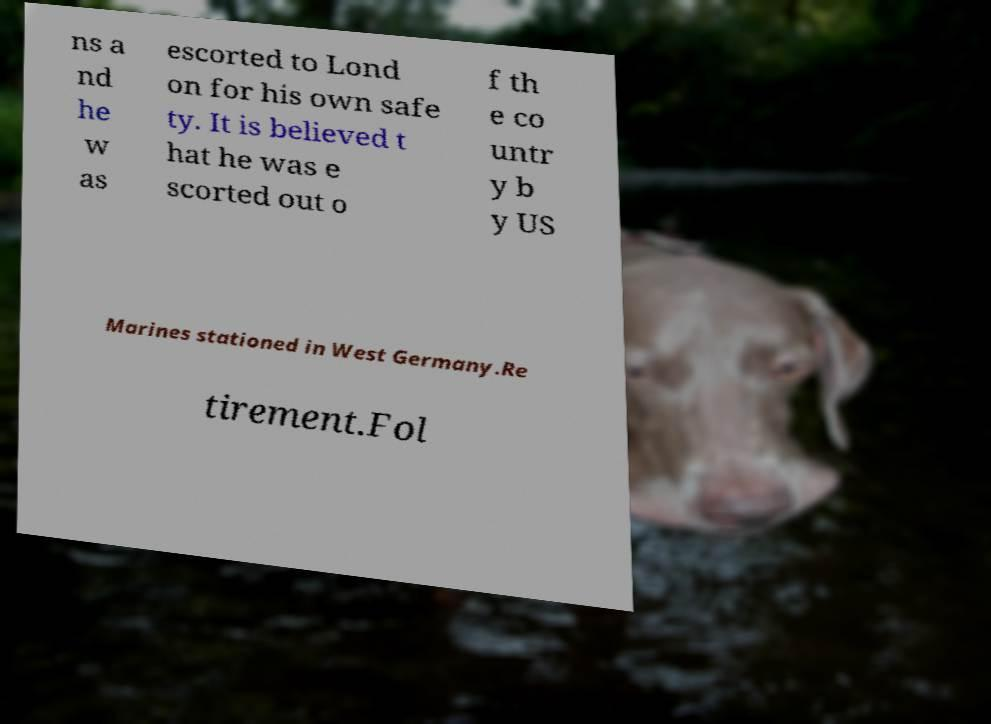Can you accurately transcribe the text from the provided image for me? ns a nd he w as escorted to Lond on for his own safe ty. It is believed t hat he was e scorted out o f th e co untr y b y US Marines stationed in West Germany.Re tirement.Fol 